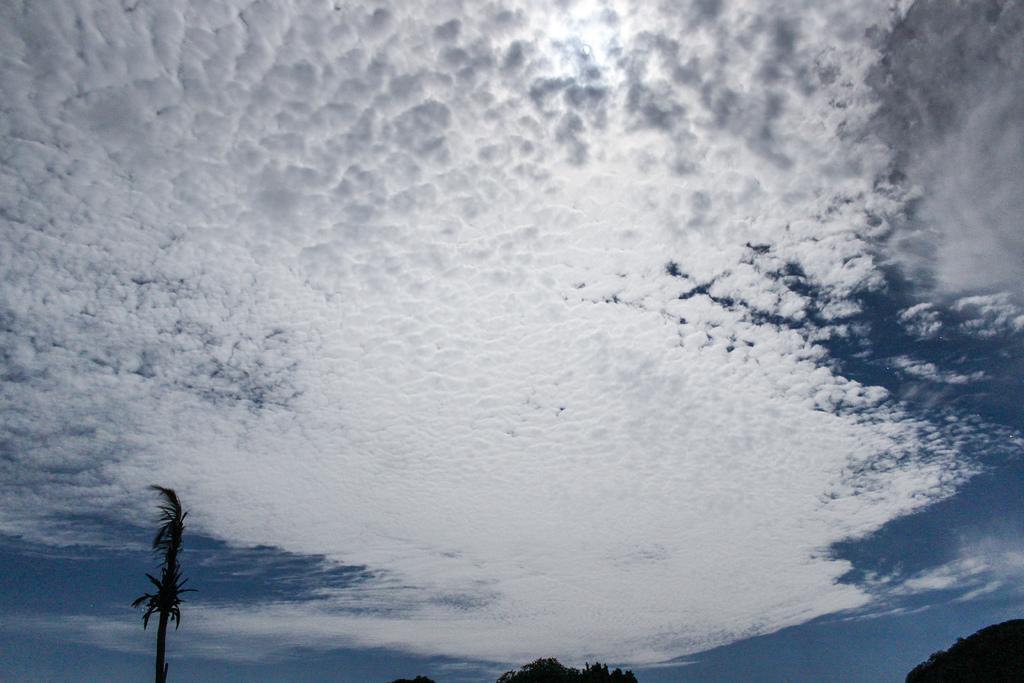Describe this image in one or two sentences. Here in this picture we can see the sky is fully covered with clouds over there and we can also see trees present over there. 